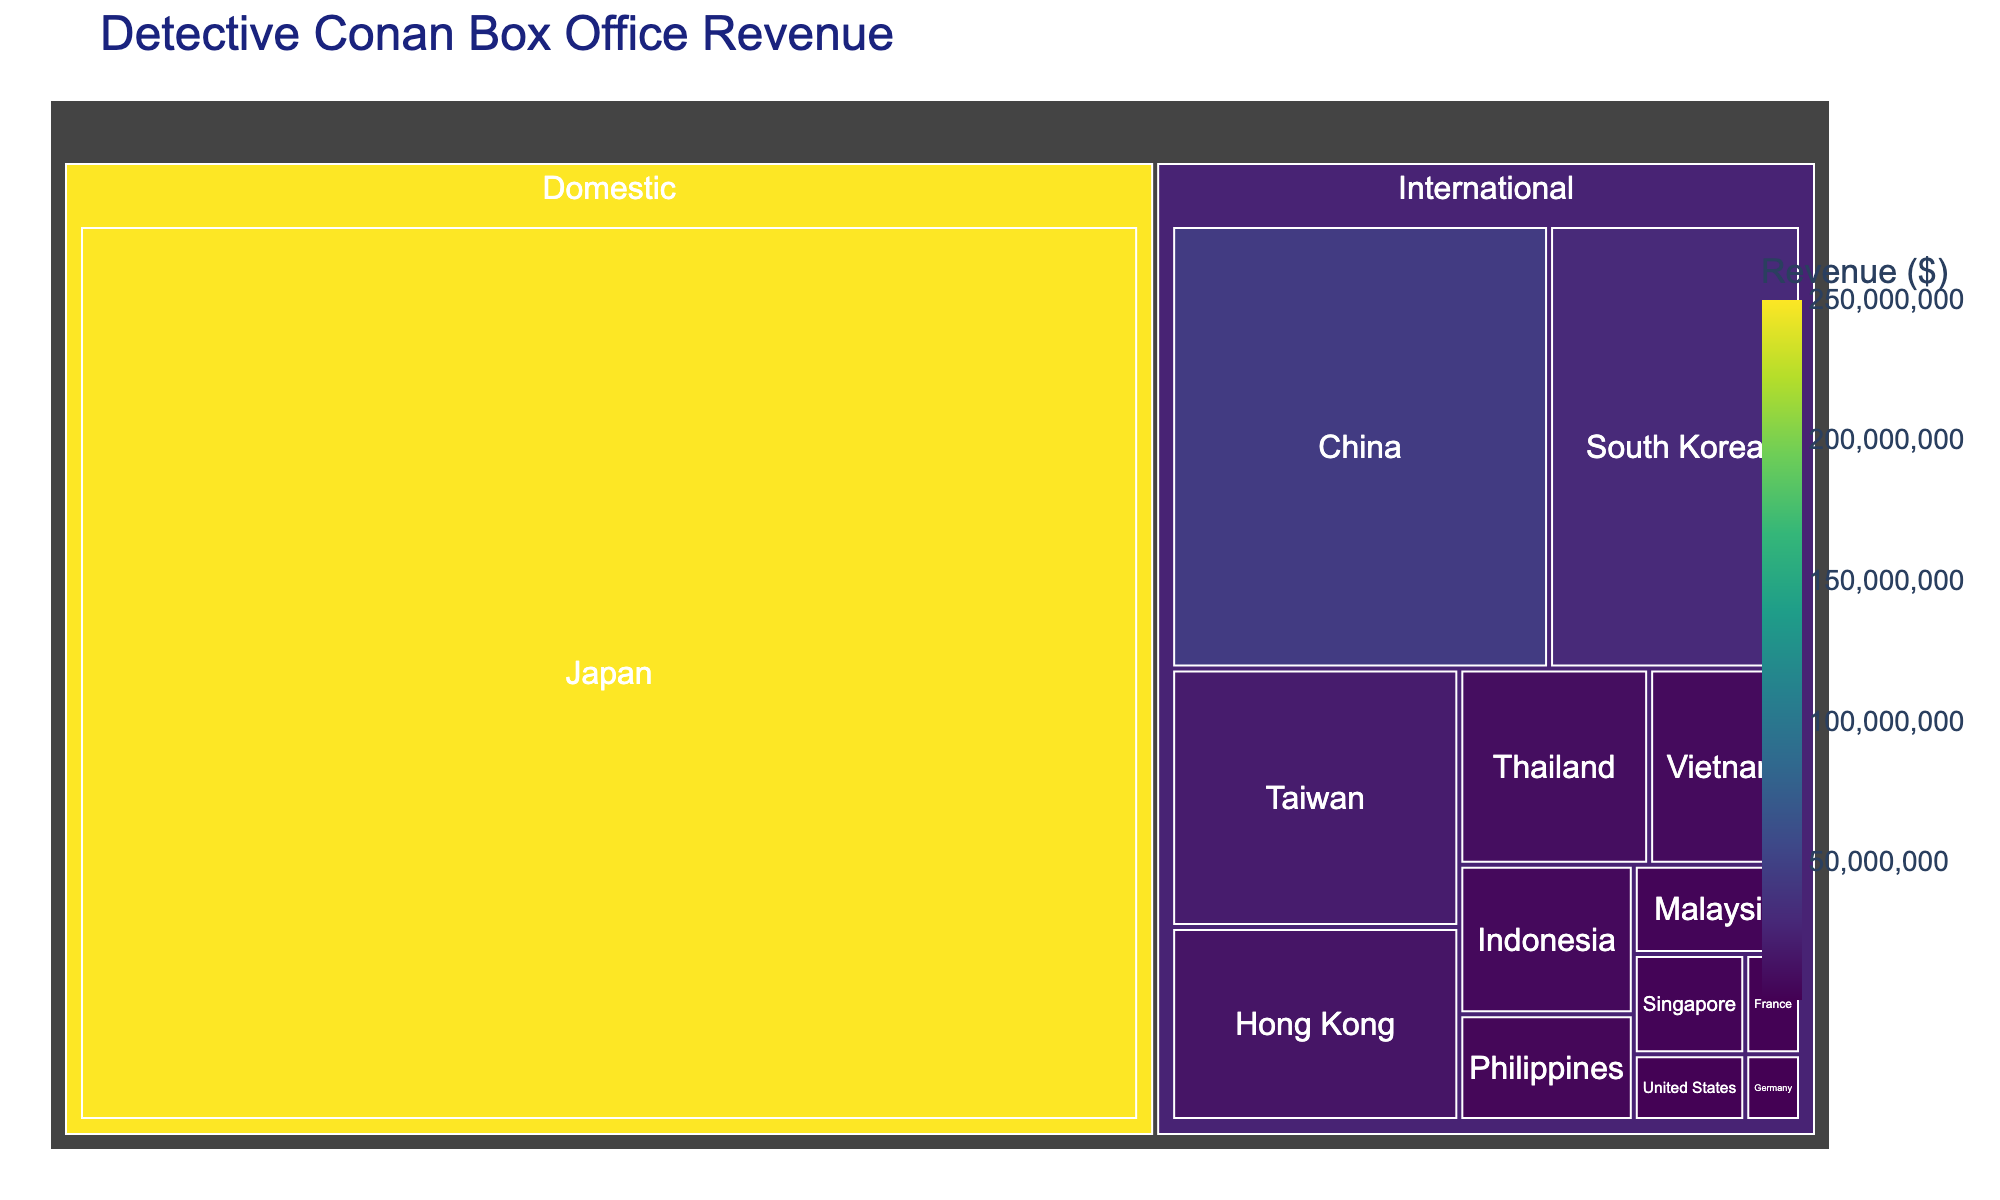Which country has the highest box office revenue from Detective Conan movies? The Treemap shows that Japan has the highest box office revenue among all countries. This is indicated by the largest tile in the "Domestic" category.
Answer: Japan What is the combined box office revenue from China and South Korea? The Treemap reveals that China's revenue is $45,000,000 and South Korea's is $30,000,000. Summing these amounts gives $75,000,000.
Answer: $75,000,000 Which country contributes the least to the international box office revenue? The Treemap displays the smallest tile under the "International" category, representing Germany with $1,000,000.
Answer: Germany What is the total international box office revenue for Detective Conan movies? To find the total, add the revenue from all international countries: $45,000,000 (China) + $30,000,000 (South Korea) + $20,000,000 (Taiwan) + $15,000,000 (Hong Kong) + $10,000,000 (Thailand) + $8,000,000 (Vietnam) + $7,000,000 (Indonesia) + $5,000,000 (Philippines) + $4,000,000 (Malaysia) + $3,000,000 (Singapore) + $2,000,000 (United States) + $1,500,000 (France) + $1,000,000 (Germany) = $151,500,000.
Answer: $151,500,000 What is the difference in box office revenue between Japan and all international markets combined? Japan's revenue is $250,000,000. The total international revenue is $151,500,000. The difference is $250,000,000 - $151,500,000 = $98,500,000.
Answer: $98,500,000 How does Taiwan's box office revenue compare to that of Hong Kong? Taiwan's revenue is $20,000,000 whereas Hong Kong's is $15,000,000. Taiwan has earned $5,000,000 more.
Answer: Taiwan Which region has more diversified revenue contributions, domestic or international? The Treemap shows multiple countries contributing to the international revenue whereas Japan is the only country in the domestic category. Thus, the international market has more diversified contributions.
Answer: International What percentage of the total box office revenue comes from Japan? First, find the total revenue: $250,000,000 (Japan) + $151,500,000 (International) = $401,500,000. Then, calculate Japan's percentage: ($250,000,000 / $401,500,000) * 100 ≈ 62.26%.
Answer: 62.26% Which country's revenue is closest to $10,000,000? The Treemap displays that Thailand's revenue is exactly $10,000,000. No other country's revenue is closer.
Answer: Thailand 